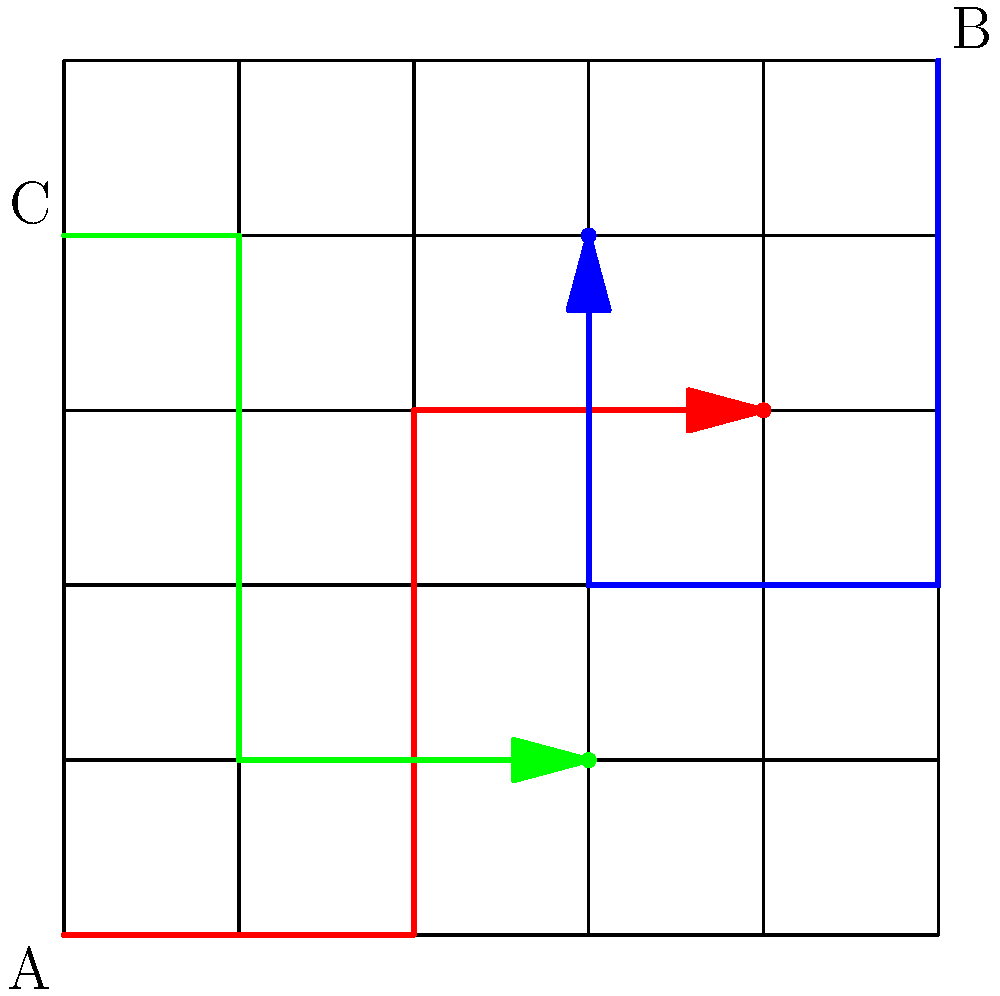You're tracking three suspects in a city grid. Suspect A starts at the southwest corner, B at the northeast corner, and C at the northwest corner. Each moves along their respective colored paths. At which intersection do the paths of all three suspects come closest to meeting? To solve this, let's analyze the paths of each suspect:

1. Suspect A (red path):
   - Moves 2 blocks east
   - Then 3 blocks north
   - Ends at (4,3)

2. Suspect B (blue path):
   - Moves 3 blocks south
   - Then 2 blocks west
   - Ends at (3,4)

3. Suspect C (green path):
   - Moves 1 block east
   - Then 3 blocks south
   - Then 2 blocks east
   - Ends at (3,1)

4. Analyzing the final positions:
   - A: (4,3)
   - B: (3,4)
   - C: (3,1)

5. The intersection where they come closest to meeting is (3,3), because:
   - It's 1 block west of A's final position
   - It's 1 block south of B's final position
   - It's 2 blocks north of C's final position

This is the point where the Manhattan distance (city block distance) between all three suspects is minimized.
Answer: (3,3) 